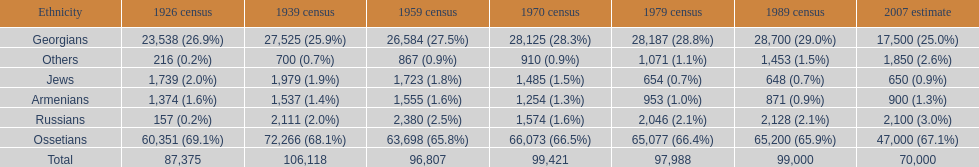How many ethnicities were below 1,000 people in 2007? 2. 